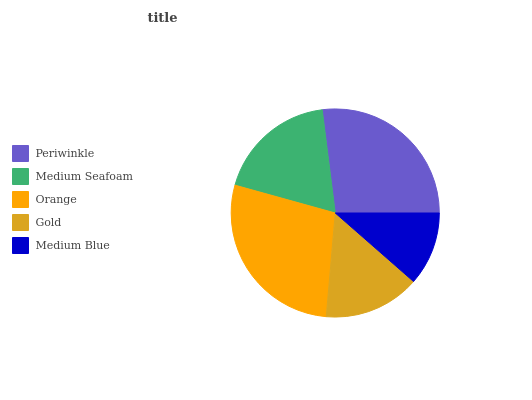Is Medium Blue the minimum?
Answer yes or no. Yes. Is Orange the maximum?
Answer yes or no. Yes. Is Medium Seafoam the minimum?
Answer yes or no. No. Is Medium Seafoam the maximum?
Answer yes or no. No. Is Periwinkle greater than Medium Seafoam?
Answer yes or no. Yes. Is Medium Seafoam less than Periwinkle?
Answer yes or no. Yes. Is Medium Seafoam greater than Periwinkle?
Answer yes or no. No. Is Periwinkle less than Medium Seafoam?
Answer yes or no. No. Is Medium Seafoam the high median?
Answer yes or no. Yes. Is Medium Seafoam the low median?
Answer yes or no. Yes. Is Orange the high median?
Answer yes or no. No. Is Medium Blue the low median?
Answer yes or no. No. 